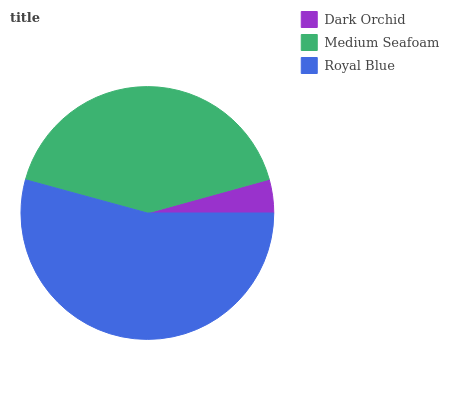Is Dark Orchid the minimum?
Answer yes or no. Yes. Is Royal Blue the maximum?
Answer yes or no. Yes. Is Medium Seafoam the minimum?
Answer yes or no. No. Is Medium Seafoam the maximum?
Answer yes or no. No. Is Medium Seafoam greater than Dark Orchid?
Answer yes or no. Yes. Is Dark Orchid less than Medium Seafoam?
Answer yes or no. Yes. Is Dark Orchid greater than Medium Seafoam?
Answer yes or no. No. Is Medium Seafoam less than Dark Orchid?
Answer yes or no. No. Is Medium Seafoam the high median?
Answer yes or no. Yes. Is Medium Seafoam the low median?
Answer yes or no. Yes. Is Dark Orchid the high median?
Answer yes or no. No. Is Royal Blue the low median?
Answer yes or no. No. 